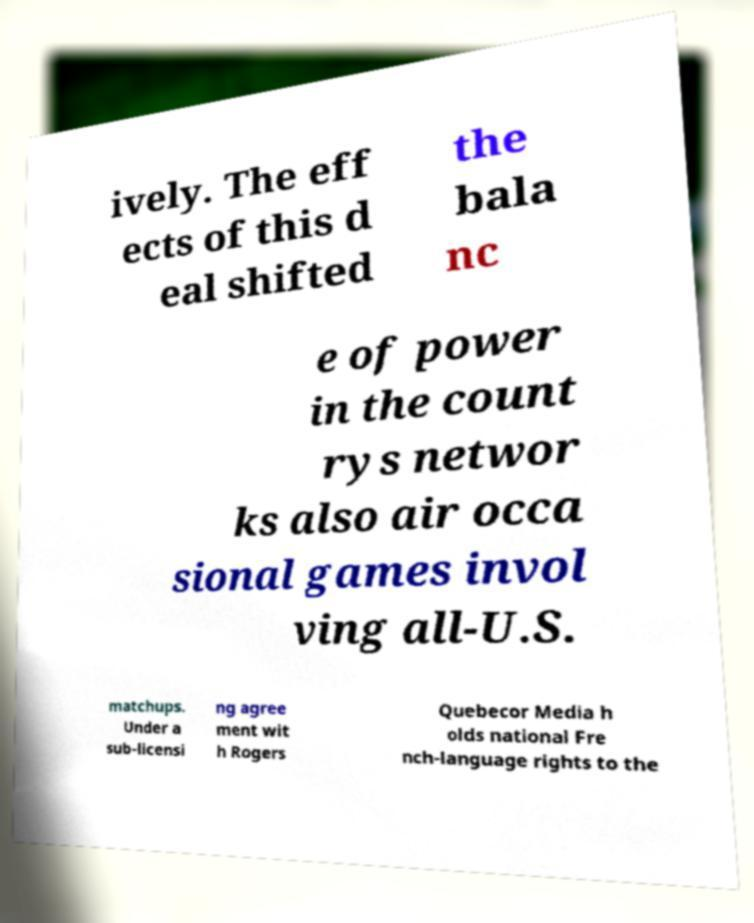Can you accurately transcribe the text from the provided image for me? ively. The eff ects of this d eal shifted the bala nc e of power in the count rys networ ks also air occa sional games invol ving all-U.S. matchups. Under a sub-licensi ng agree ment wit h Rogers Quebecor Media h olds national Fre nch-language rights to the 